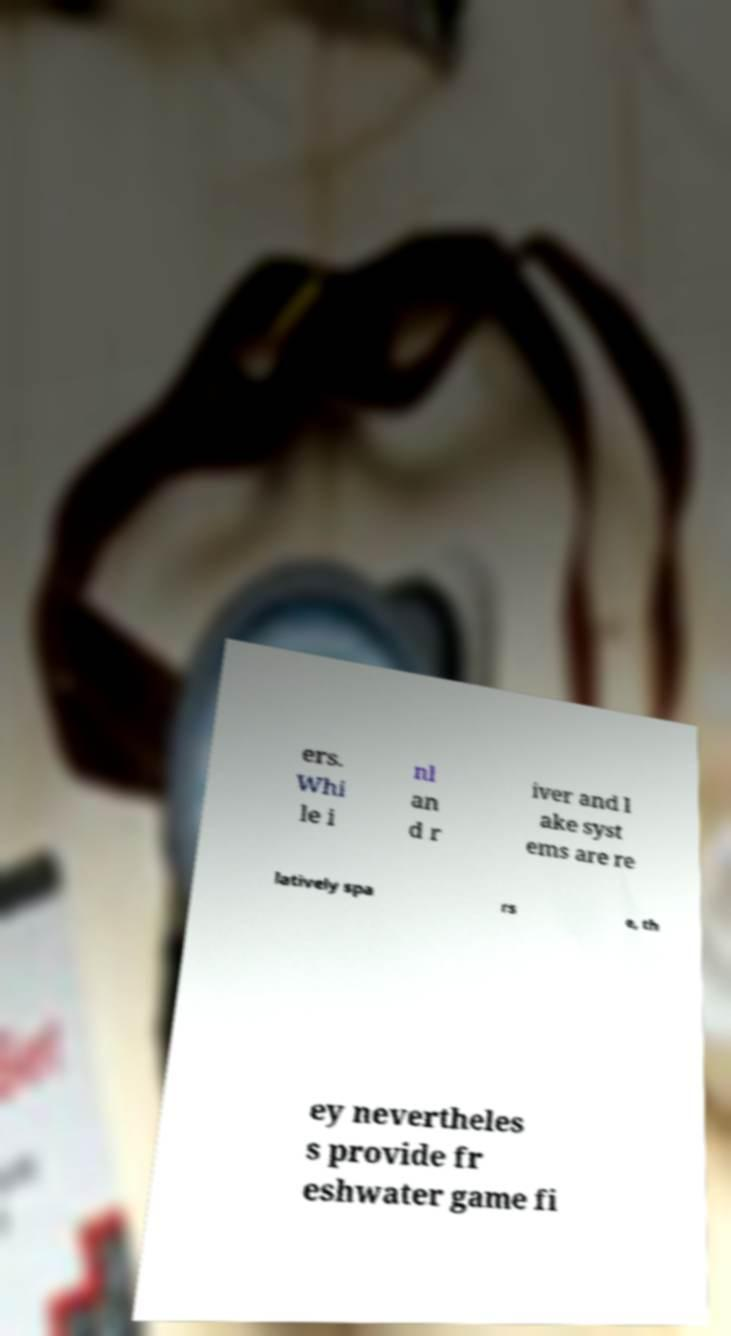Please read and relay the text visible in this image. What does it say? ers. Whi le i nl an d r iver and l ake syst ems are re latively spa rs e, th ey nevertheles s provide fr eshwater game fi 